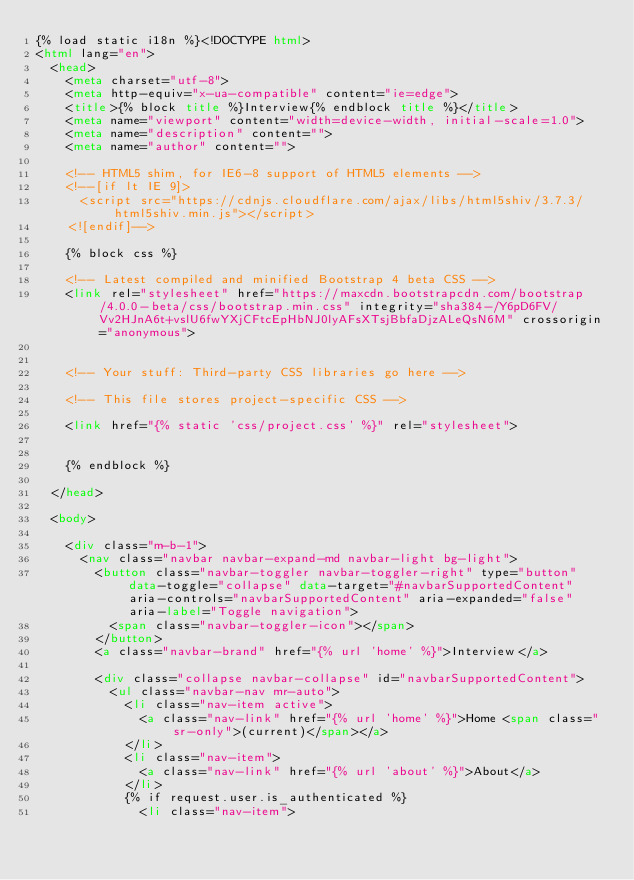<code> <loc_0><loc_0><loc_500><loc_500><_HTML_>{% load static i18n %}<!DOCTYPE html>
<html lang="en">
  <head>
    <meta charset="utf-8">
    <meta http-equiv="x-ua-compatible" content="ie=edge">
    <title>{% block title %}Interview{% endblock title %}</title>
    <meta name="viewport" content="width=device-width, initial-scale=1.0">
    <meta name="description" content="">
    <meta name="author" content="">

    <!-- HTML5 shim, for IE6-8 support of HTML5 elements -->
    <!--[if lt IE 9]>
      <script src="https://cdnjs.cloudflare.com/ajax/libs/html5shiv/3.7.3/html5shiv.min.js"></script>
    <![endif]-->

    {% block css %}
    
    <!-- Latest compiled and minified Bootstrap 4 beta CSS -->
    <link rel="stylesheet" href="https://maxcdn.bootstrapcdn.com/bootstrap/4.0.0-beta/css/bootstrap.min.css" integrity="sha384-/Y6pD6FV/Vv2HJnA6t+vslU6fwYXjCFtcEpHbNJ0lyAFsXTsjBbfaDjzALeQsN6M" crossorigin="anonymous">
    

    <!-- Your stuff: Third-party CSS libraries go here -->
    
    <!-- This file stores project-specific CSS -->
    
    <link href="{% static 'css/project.css' %}" rel="stylesheet">
    
    
    {% endblock %}

  </head>

  <body>

    <div class="m-b-1">
      <nav class="navbar navbar-expand-md navbar-light bg-light">
        <button class="navbar-toggler navbar-toggler-right" type="button" data-toggle="collapse" data-target="#navbarSupportedContent" aria-controls="navbarSupportedContent" aria-expanded="false" aria-label="Toggle navigation">
          <span class="navbar-toggler-icon"></span>
        </button>
        <a class="navbar-brand" href="{% url 'home' %}">Interview</a>

        <div class="collapse navbar-collapse" id="navbarSupportedContent">
          <ul class="navbar-nav mr-auto">
            <li class="nav-item active">
              <a class="nav-link" href="{% url 'home' %}">Home <span class="sr-only">(current)</span></a>
            </li>
            <li class="nav-item">
              <a class="nav-link" href="{% url 'about' %}">About</a>
            </li>
            {% if request.user.is_authenticated %}
              <li class="nav-item"></code> 